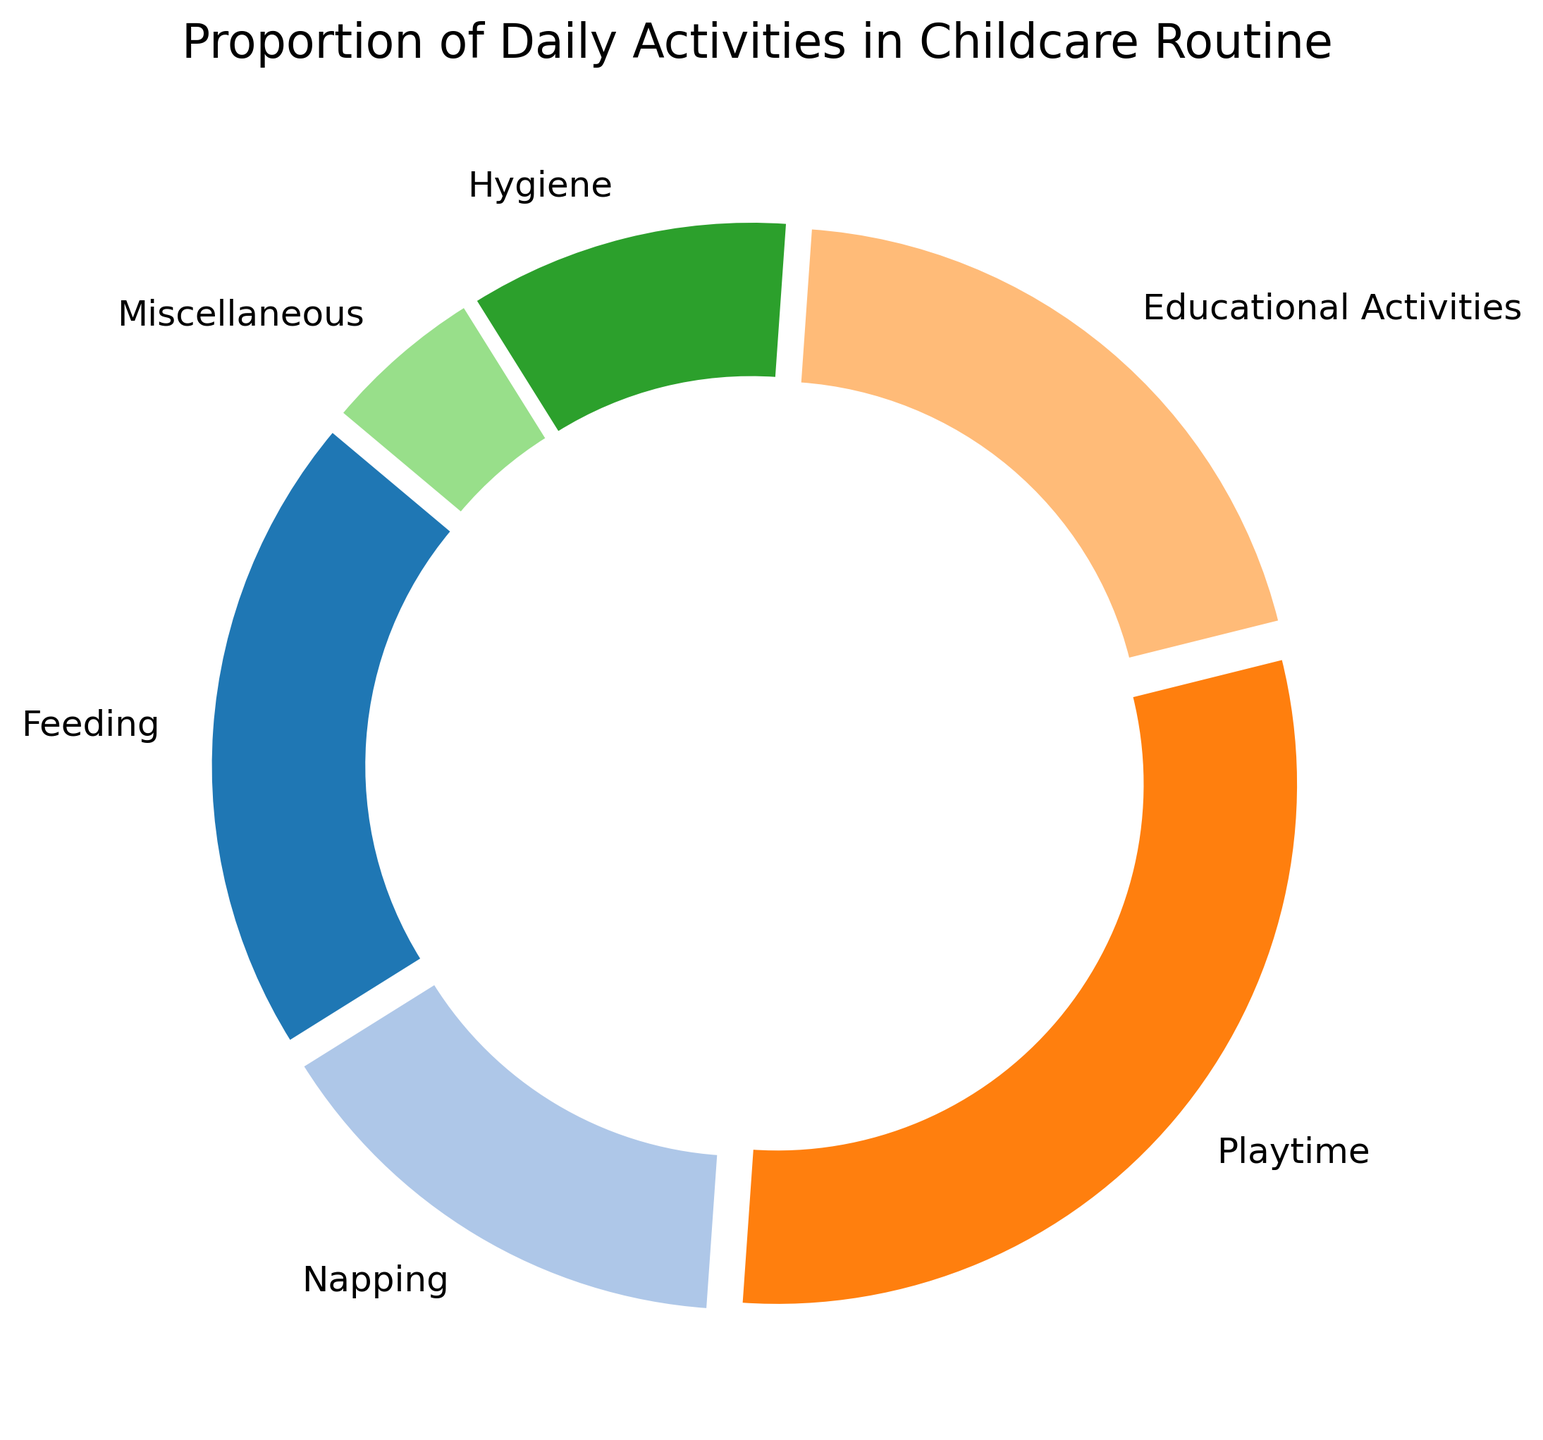What activity has the largest proportion of the childcare routine? By looking at the pie chart, the activity segment with the largest area will also have the highest percentage label.
Answer: Playtime Which two activities together constitute less than half of the child's routine? Adding the proportions of Feeding (20%) and Miscellaneous (5%) results in 25%, and Napping (15%) and Hygiene (10%) results in 25%. Any pair yielding less than 50% fulfills the condition.
Answer: Napping and Hygiene What's the total proportion of Feeding and Educational Activities? Sum the proportions of Feeding (20%) and Educational Activities (20%). 20% + 20% = 40%
Answer: 40% How does the proportion of Playtime compare to the proportion of Hygiene? Compare the proportions by subtracting the smaller from the larger: 30% (Playtime) - 10% (Hygiene) = 20%
Answer: 30% of Playtime is greater than 10% of Hygiene by 20% What color represents the activity with the smallest proportion? Determine the activity with the smallest percentage (Miscellaneous, 5%) and identify its color from the pie chart.
Answer: Miscellaneous, identified by its respective color Is the proportion of Feeding equal to the proportion of Educational Activities? Compare the proportions labeled for Feeding (20%) and Educational Activities (20%). 20% = 20%
Answer: Yes How many activities have a proportion of 20% or more? Count the activities with proportions 20% or above: Feeding (20%), Playtime (30%), and Educational Activities (20%). Only three activities meet this criterion.
Answer: Three activities What's the average proportion of Napping, Hygiene, and Miscellaneous activities? Calculate the average by summing Napping (15%), Hygiene (10%), Miscellaneous (5%), and dividing by three. (15% + 10% + 5%) / 3 = 10%
Answer: 10% 